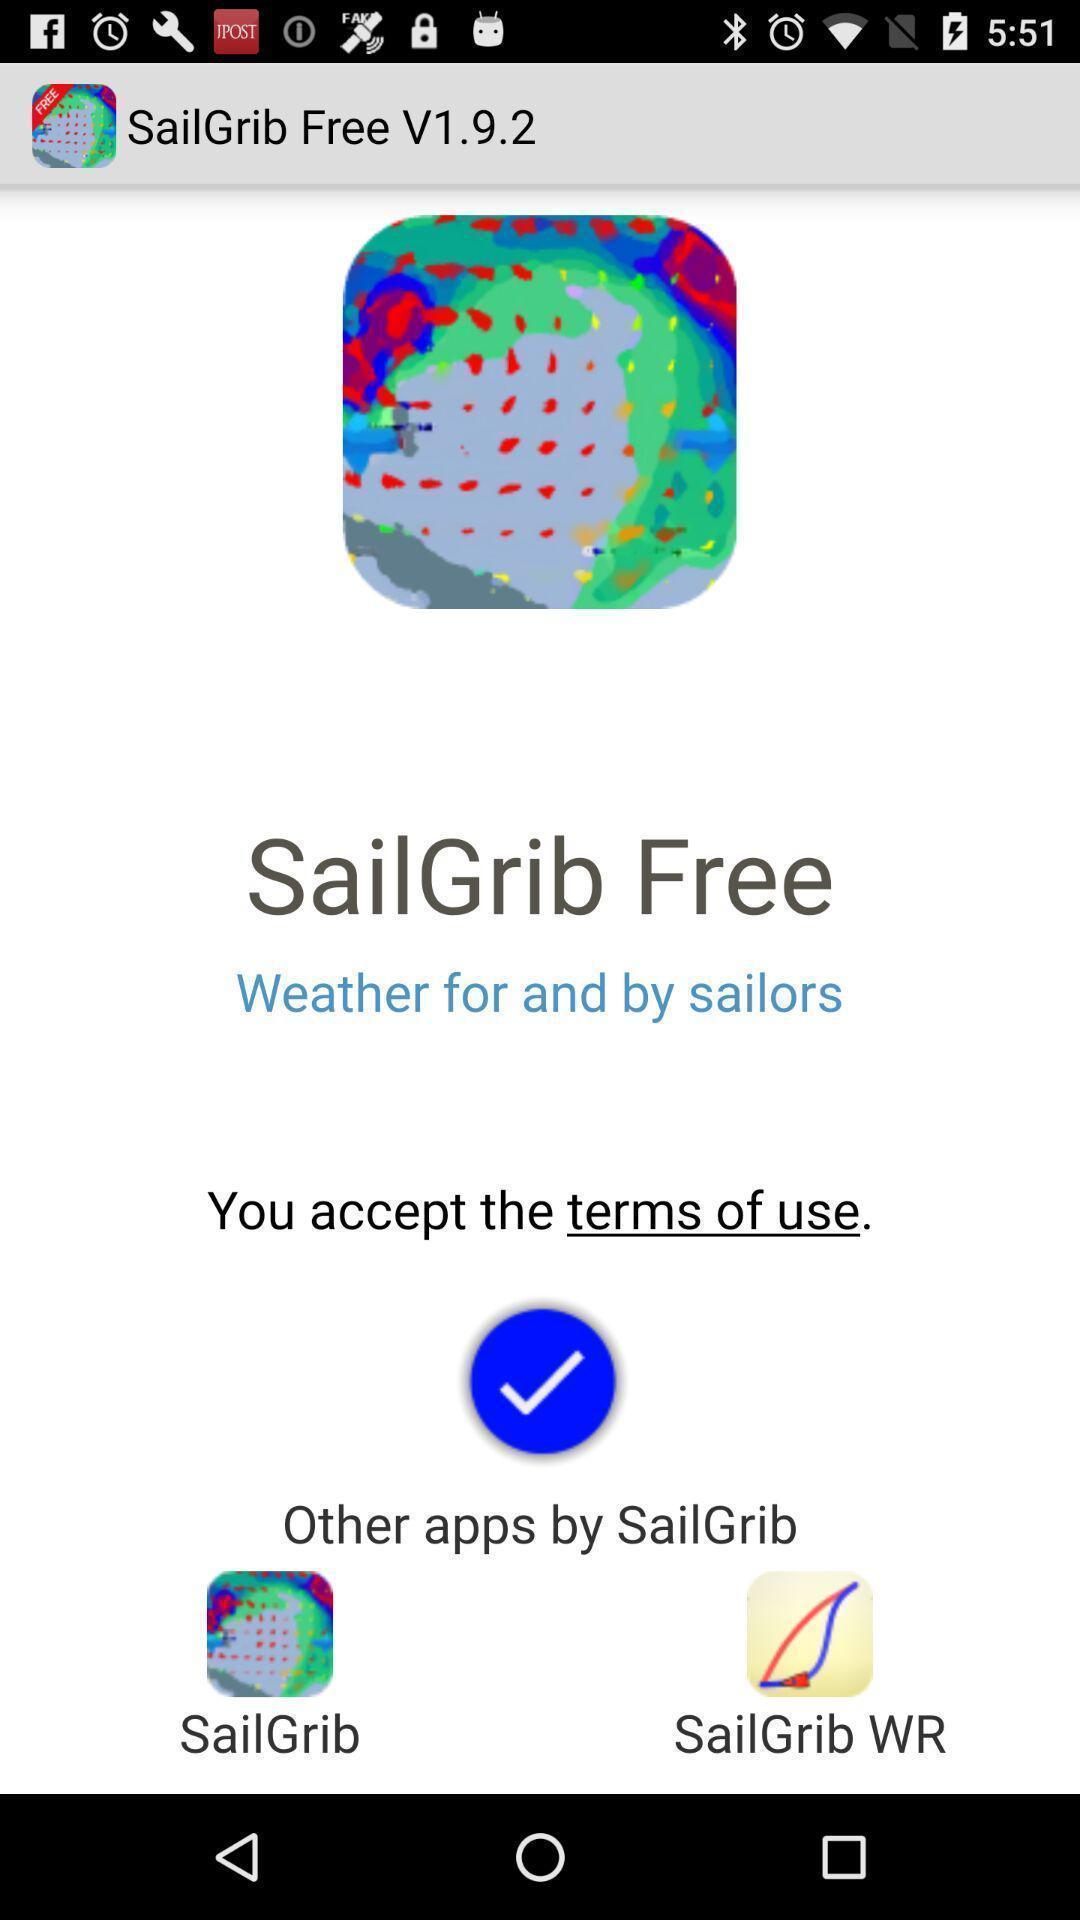Describe the visual elements of this screenshot. Welcome screen. 